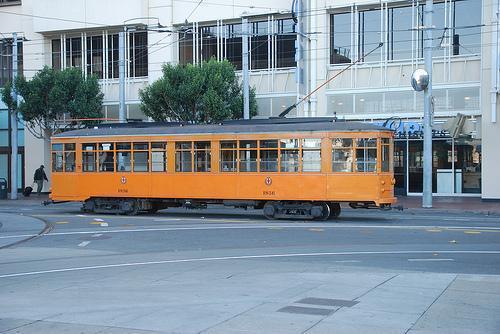How many people are outside?
Give a very brief answer. 1. 